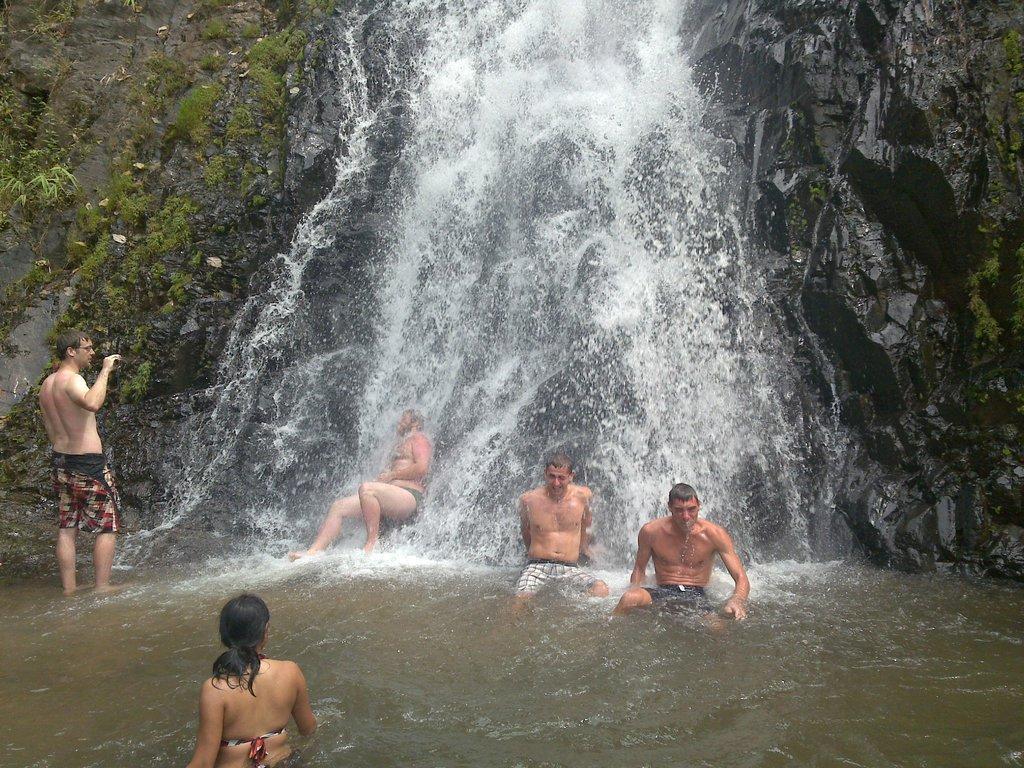Please provide a concise description of this image. In this image I can see the waterfalls. At the bottom there are few people in the water. On the left side a man is standing and also I can see some plants. On the right side there is a rock. 